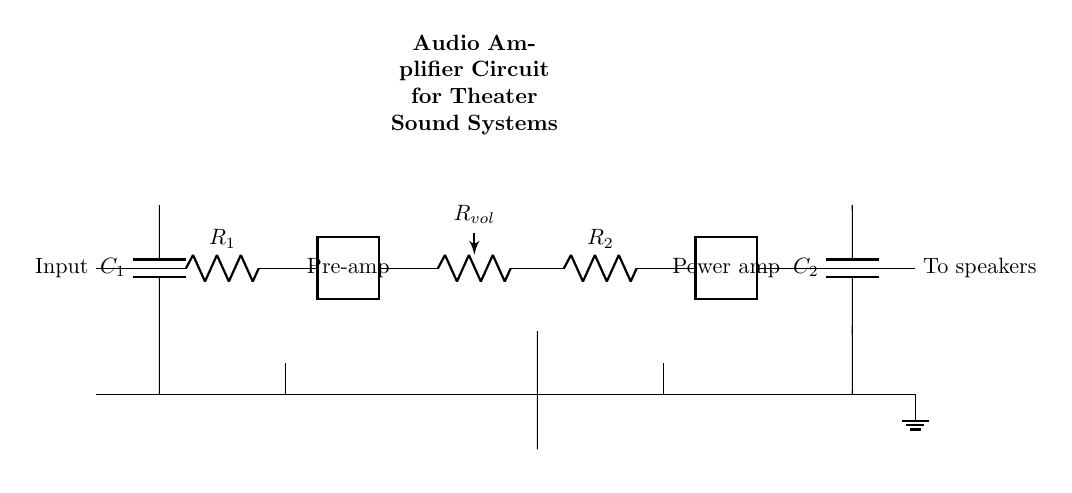What is the input in this circuit? The input is connected to the left side of the circuit diagram labeled as "Input." This represents the source of the audio signal that will be amplified.
Answer: Input What is the function of the component labeled “Power amp”? The "Power amp" component amplifies the audio signal received from the pre-amp stage to a higher power suitable for driving speakers. It increases the signal strength to the levels needed for audio output.
Answer: Amplification How many capacitors are present in this circuit? There are two capacitors in the circuit, C1 and C2, which are used for coupling and filtering purposes in the audio signal path.
Answer: Two What does the component labeled $R_{vol}$ represent? The component $R_{vol}$ represents the volume control which adjusts the amplitude of the audio signal before it passes to the power amplifier stage.
Answer: Volume control Why does the circuit include a "Pre-amp" stage? The "Pre-amp" stage is included to boost weak audio signals from the input source to a higher level suitable for further amplification. This stage provides initial gain to ensure clear sound quality.
Answer: Initial gain What do the connections labeled “To speakers” indicate? The labeled connections “To speakers” indicate the output of the amplified audio signal, which will be sent to the speakers for playback in the theater sound system.
Answer: Output to speakers 